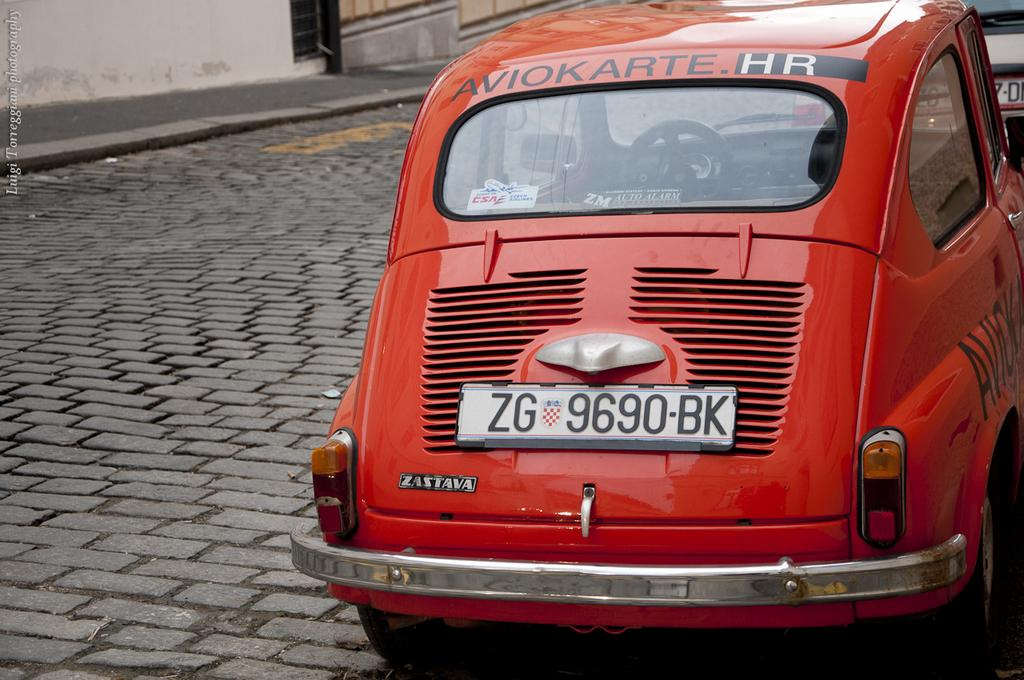What is located in the front of the image? There are vehicles on the road in the image. What type of structures can be seen in the background of the image? There is a wall visible in the background of the image. What type of button can be seen being compared by the vehicles in the image? There is no button present in the image, and the vehicles are not engaged in any comparison activity. 